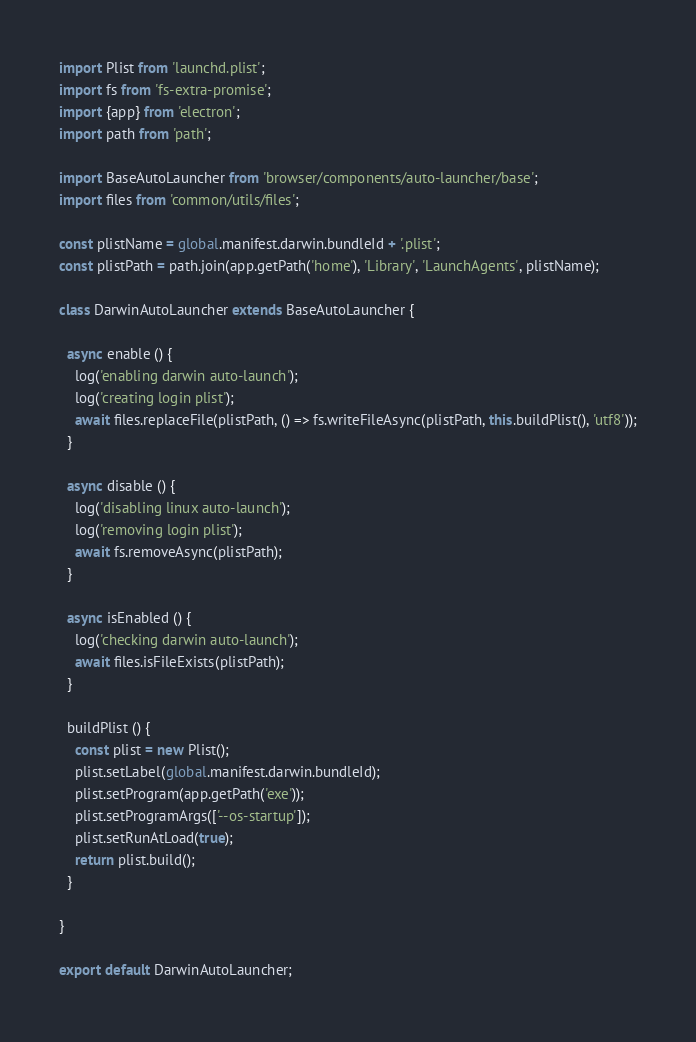<code> <loc_0><loc_0><loc_500><loc_500><_JavaScript_>import Plist from 'launchd.plist';
import fs from 'fs-extra-promise';
import {app} from 'electron';
import path from 'path';

import BaseAutoLauncher from 'browser/components/auto-launcher/base';
import files from 'common/utils/files';

const plistName = global.manifest.darwin.bundleId + '.plist';
const plistPath = path.join(app.getPath('home'), 'Library', 'LaunchAgents', plistName);

class DarwinAutoLauncher extends BaseAutoLauncher {

  async enable () {
    log('enabling darwin auto-launch');
    log('creating login plist');
    await files.replaceFile(plistPath, () => fs.writeFileAsync(plistPath, this.buildPlist(), 'utf8'));
  }

  async disable () {
    log('disabling linux auto-launch');
    log('removing login plist');
    await fs.removeAsync(plistPath);
  }

  async isEnabled () {
    log('checking darwin auto-launch');
    await files.isFileExists(plistPath);
  }

  buildPlist () {
    const plist = new Plist();
    plist.setLabel(global.manifest.darwin.bundleId);
    plist.setProgram(app.getPath('exe'));
    plist.setProgramArgs(['--os-startup']);
    plist.setRunAtLoad(true);
    return plist.build();
  }

}

export default DarwinAutoLauncher;
</code> 